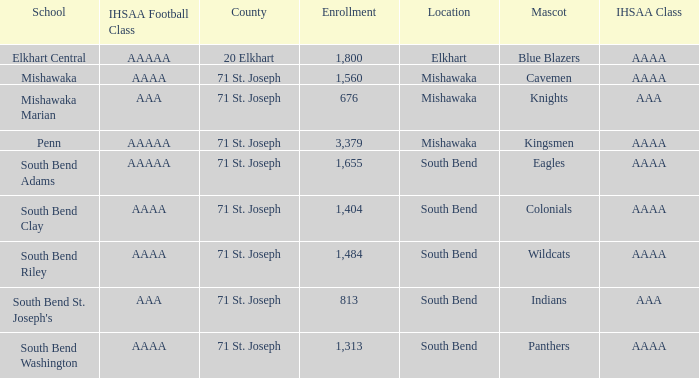What location has kingsmen as the mascot? Mishawaka. 